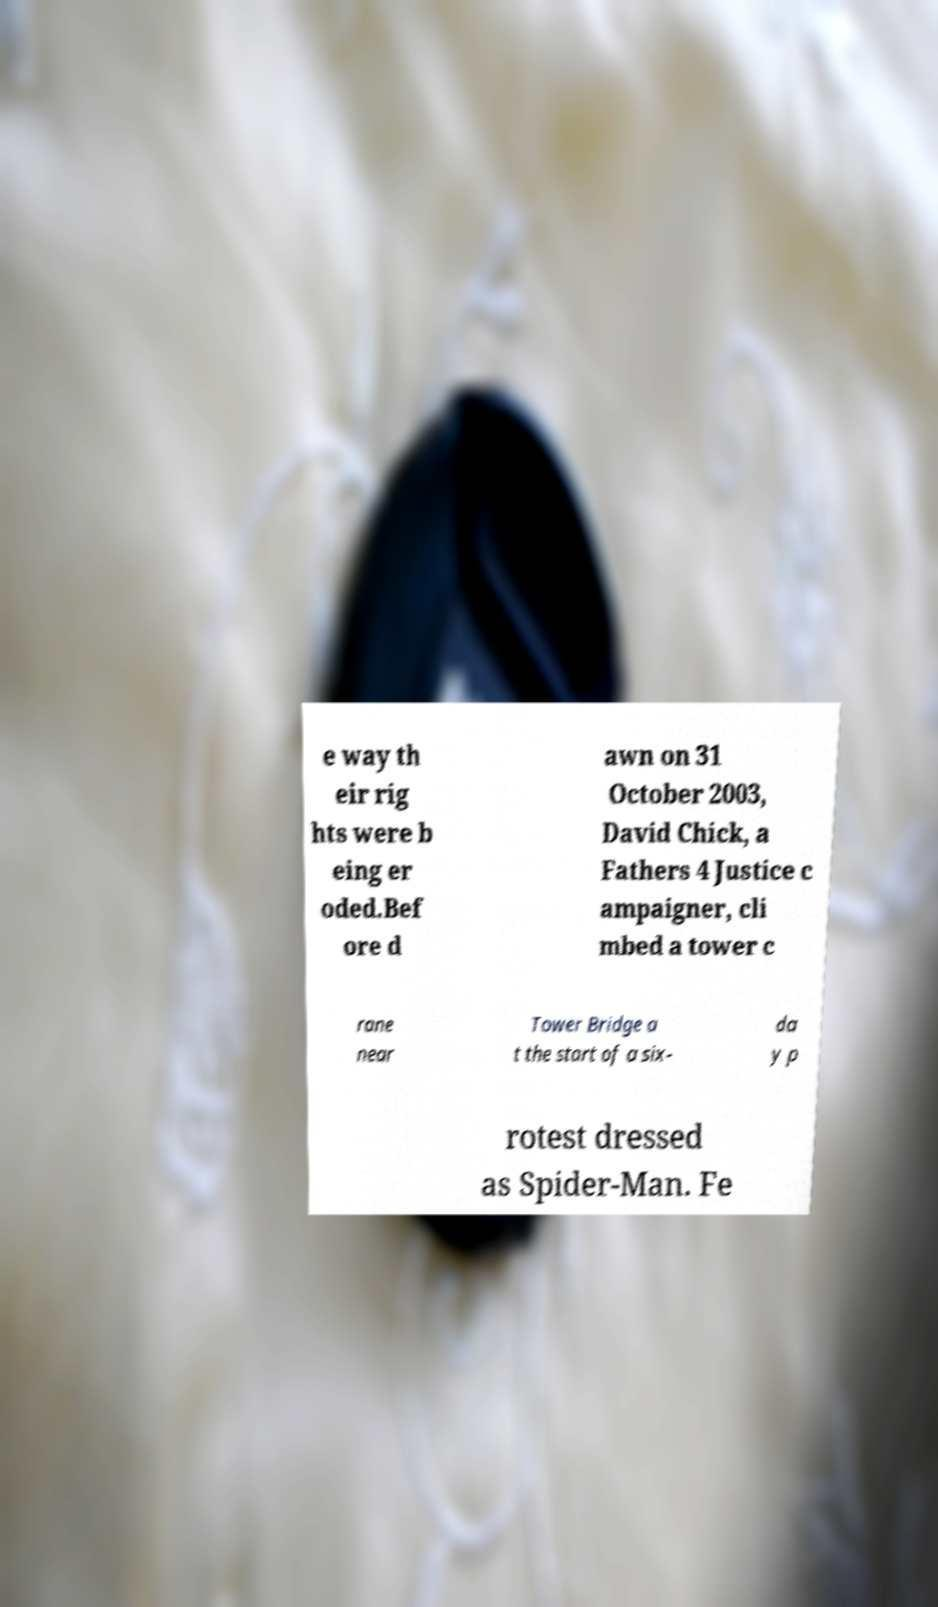Can you accurately transcribe the text from the provided image for me? e way th eir rig hts were b eing er oded.Bef ore d awn on 31 October 2003, David Chick, a Fathers 4 Justice c ampaigner, cli mbed a tower c rane near Tower Bridge a t the start of a six- da y p rotest dressed as Spider-Man. Fe 